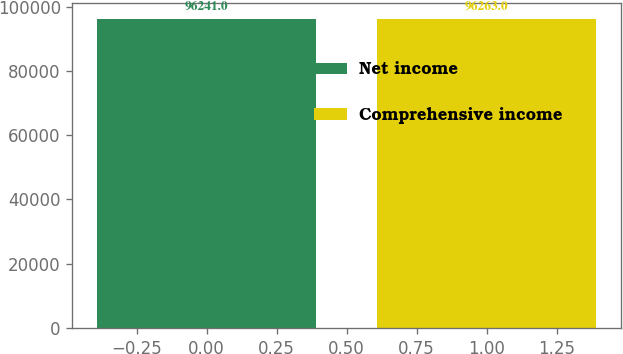<chart> <loc_0><loc_0><loc_500><loc_500><bar_chart><fcel>Net income<fcel>Comprehensive income<nl><fcel>96241<fcel>96263<nl></chart> 